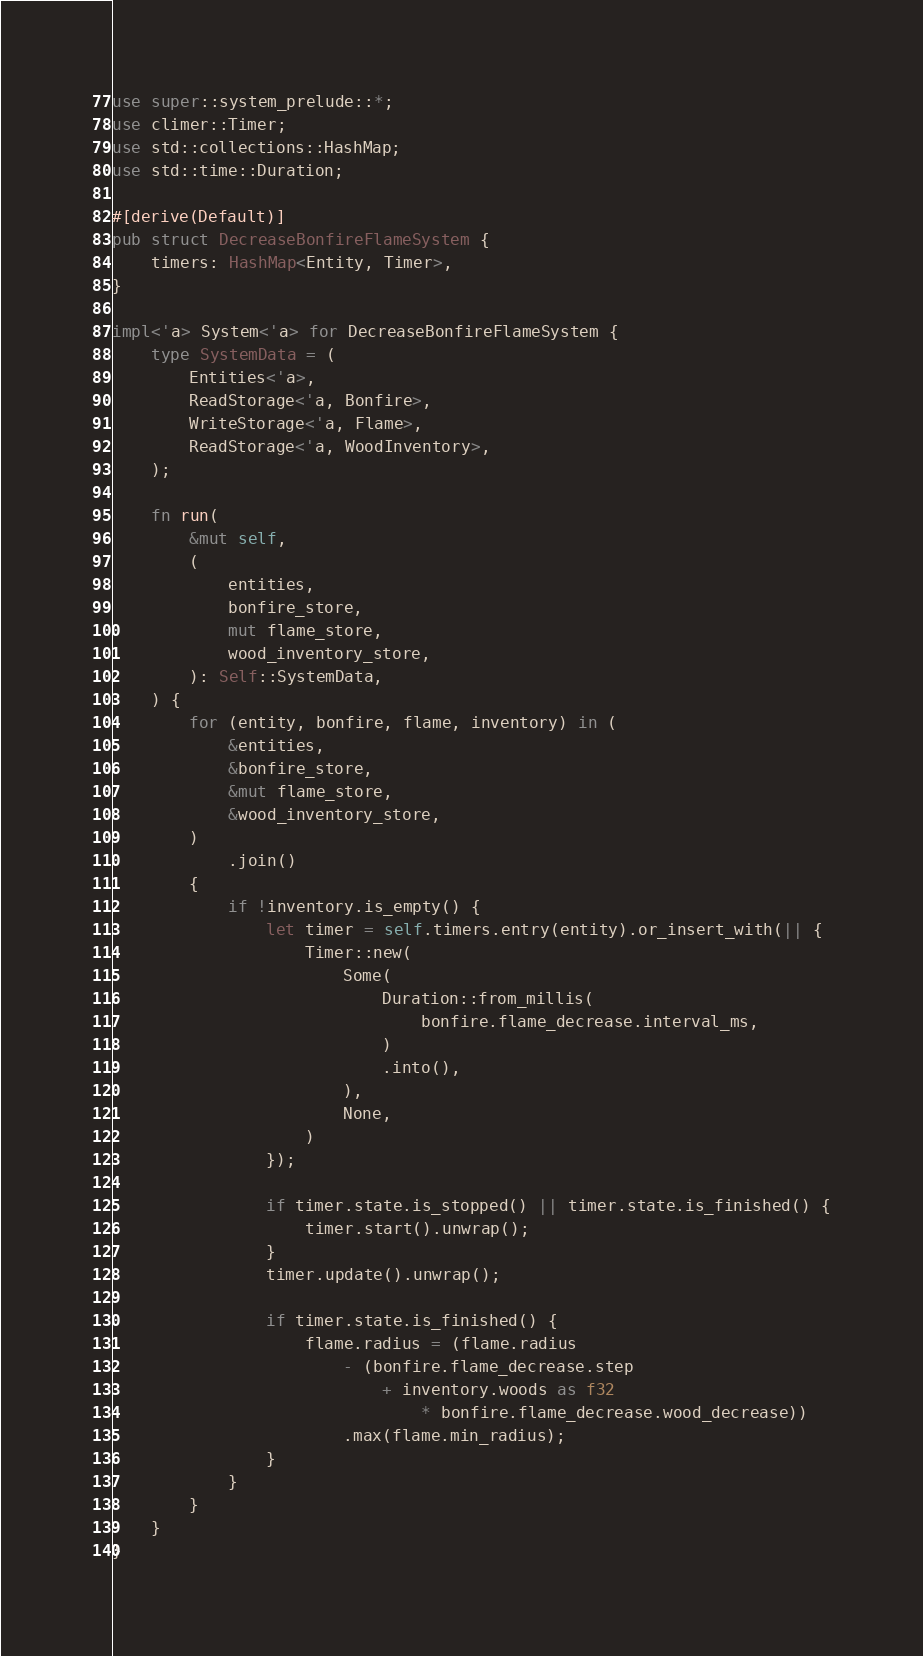Convert code to text. <code><loc_0><loc_0><loc_500><loc_500><_Rust_>use super::system_prelude::*;
use climer::Timer;
use std::collections::HashMap;
use std::time::Duration;

#[derive(Default)]
pub struct DecreaseBonfireFlameSystem {
    timers: HashMap<Entity, Timer>,
}

impl<'a> System<'a> for DecreaseBonfireFlameSystem {
    type SystemData = (
        Entities<'a>,
        ReadStorage<'a, Bonfire>,
        WriteStorage<'a, Flame>,
        ReadStorage<'a, WoodInventory>,
    );

    fn run(
        &mut self,
        (
            entities,
            bonfire_store,
            mut flame_store,
            wood_inventory_store,
        ): Self::SystemData,
    ) {
        for (entity, bonfire, flame, inventory) in (
            &entities,
            &bonfire_store,
            &mut flame_store,
            &wood_inventory_store,
        )
            .join()
        {
            if !inventory.is_empty() {
                let timer = self.timers.entry(entity).or_insert_with(|| {
                    Timer::new(
                        Some(
                            Duration::from_millis(
                                bonfire.flame_decrease.interval_ms,
                            )
                            .into(),
                        ),
                        None,
                    )
                });

                if timer.state.is_stopped() || timer.state.is_finished() {
                    timer.start().unwrap();
                }
                timer.update().unwrap();

                if timer.state.is_finished() {
                    flame.radius = (flame.radius
                        - (bonfire.flame_decrease.step
                            + inventory.woods as f32
                                * bonfire.flame_decrease.wood_decrease))
                        .max(flame.min_radius);
                }
            }
        }
    }
}
</code> 